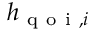Convert formula to latex. <formula><loc_0><loc_0><loc_500><loc_500>h _ { q o i , i }</formula> 